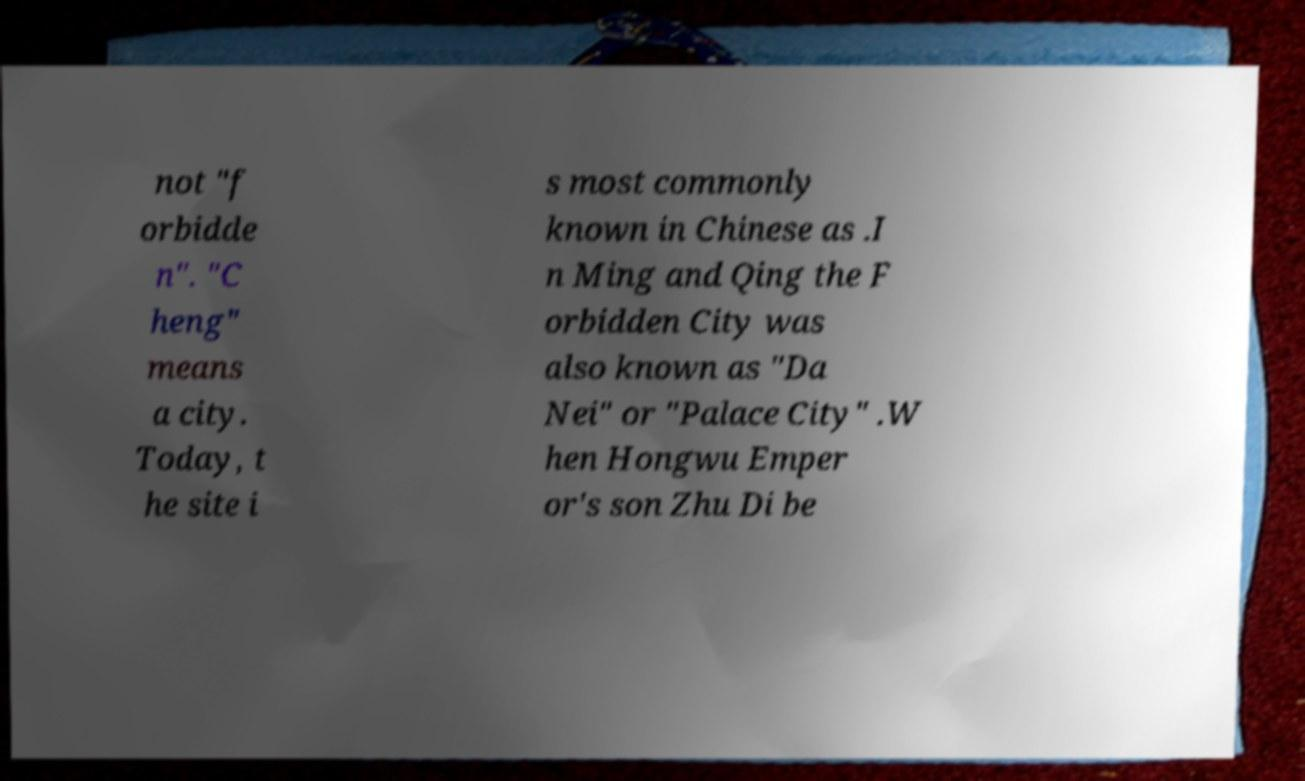Could you extract and type out the text from this image? not "f orbidde n". "C heng" means a city. Today, t he site i s most commonly known in Chinese as .I n Ming and Qing the F orbidden City was also known as "Da Nei" or "Palace City" .W hen Hongwu Emper or's son Zhu Di be 